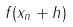<formula> <loc_0><loc_0><loc_500><loc_500>f ( x _ { n } + h )</formula> 